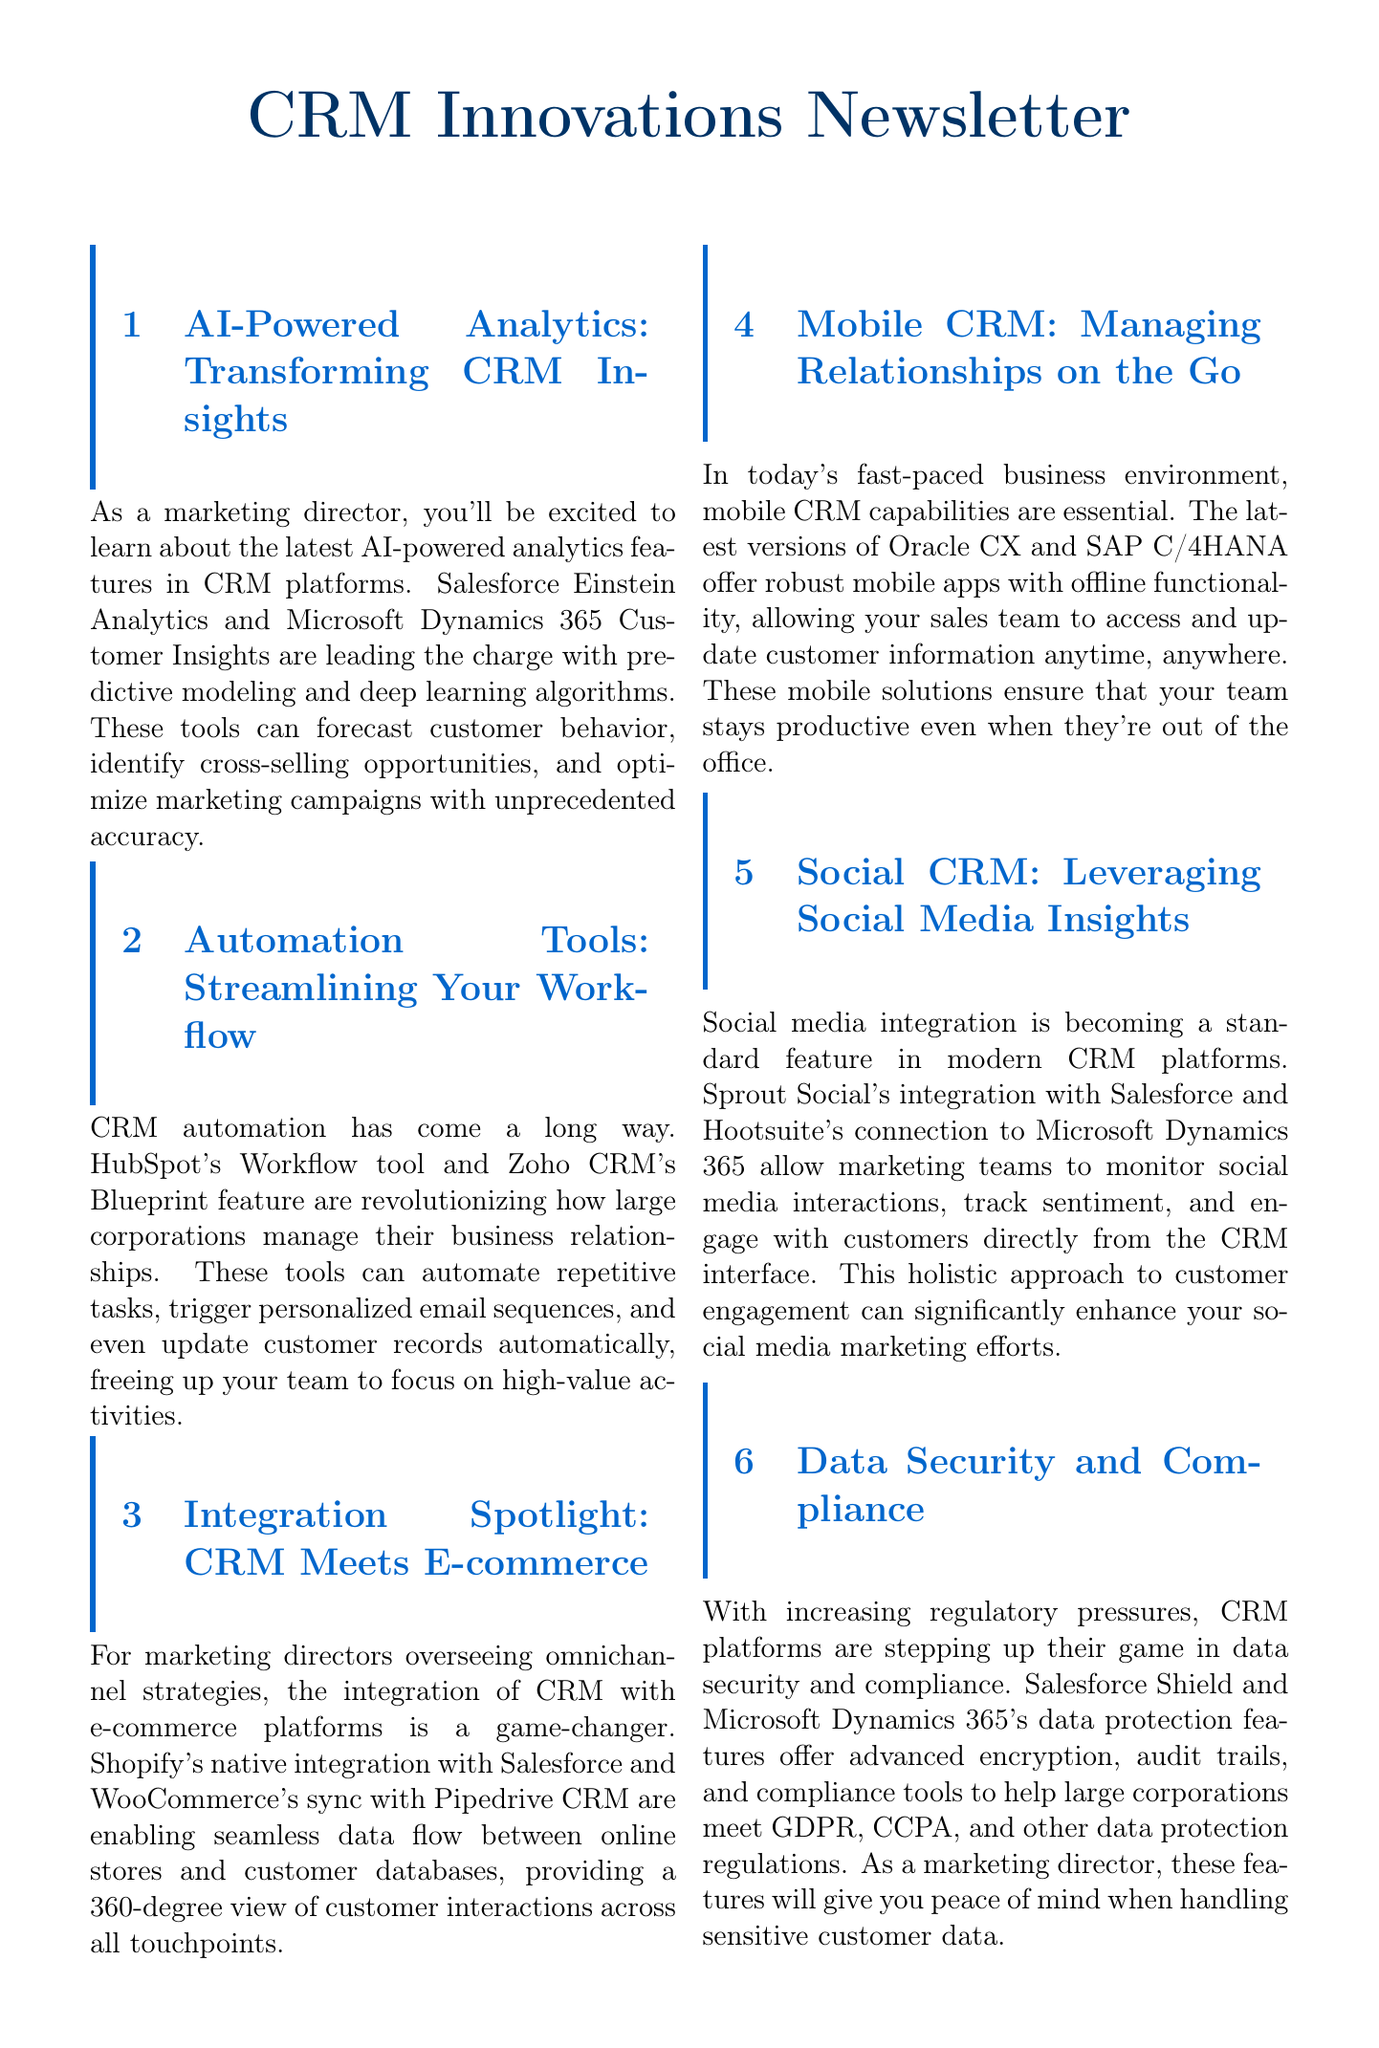What are the names of two AI-powered analytics tools mentioned? The document lists Salesforce Einstein Analytics and Microsoft Dynamics 365 Customer Insights as leading AI-powered analytics tools in CRM platforms.
Answer: Salesforce Einstein Analytics, Microsoft Dynamics 365 Customer Insights What feature allows HubSpot to automate tasks? The document states HubSpot's Workflow tool as a feature that can automate repetitive tasks for large corporations.
Answer: HubSpot's Workflow tool Which CRM platform integrates natively with Shopify? The document mentions Shopify's native integration with Salesforce as a key integration in the context of e-commerce.
Answer: Salesforce What enables mobile CRM capabilities according to the newsletter? The newsletter highlights robust mobile apps with offline functionality from Oracle CX and SAP C/4HANA as essential for mobile CRM.
Answer: Mobile apps with offline functionality What is a critical aspect of the latest CRM platforms regarding customer data? The document focuses on data security and compliance features as essential for handling sensitive customer data.
Answer: Data security and compliance Name a social media integration mentioned in the document. The document refers to Sprout Social's integration with Salesforce as an example of social media integration in modern CRM platforms.
Answer: Sprout Social's integration with Salesforce 